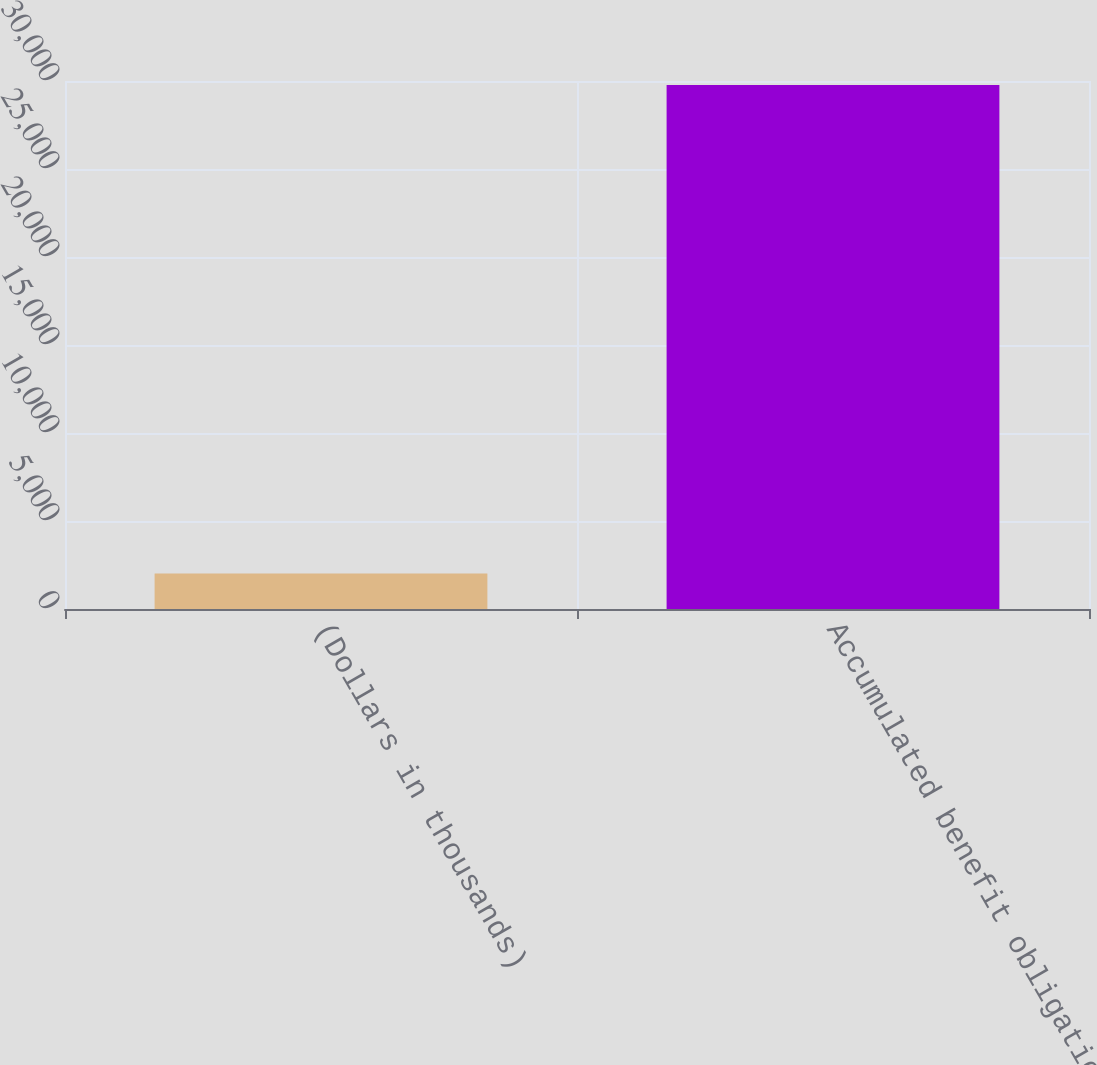Convert chart to OTSL. <chart><loc_0><loc_0><loc_500><loc_500><bar_chart><fcel>(Dollars in thousands)<fcel>Accumulated benefit obligation<nl><fcel>2013<fcel>29774<nl></chart> 